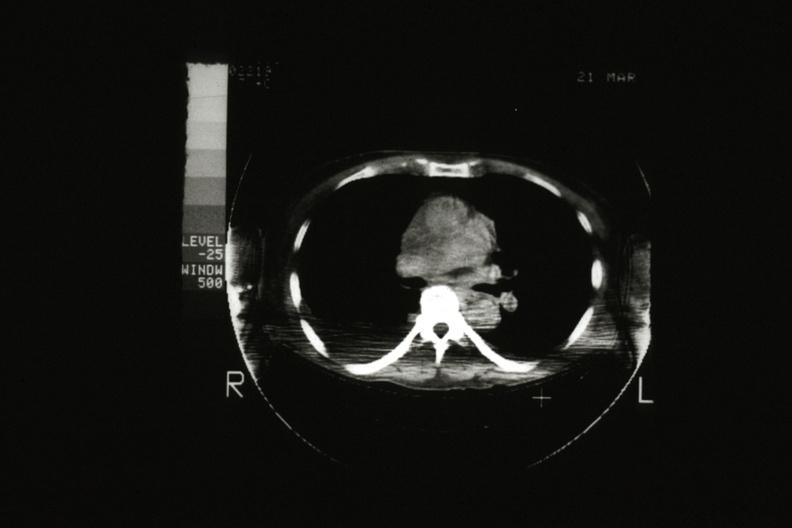what is present?
Answer the question using a single word or phrase. Thymus 